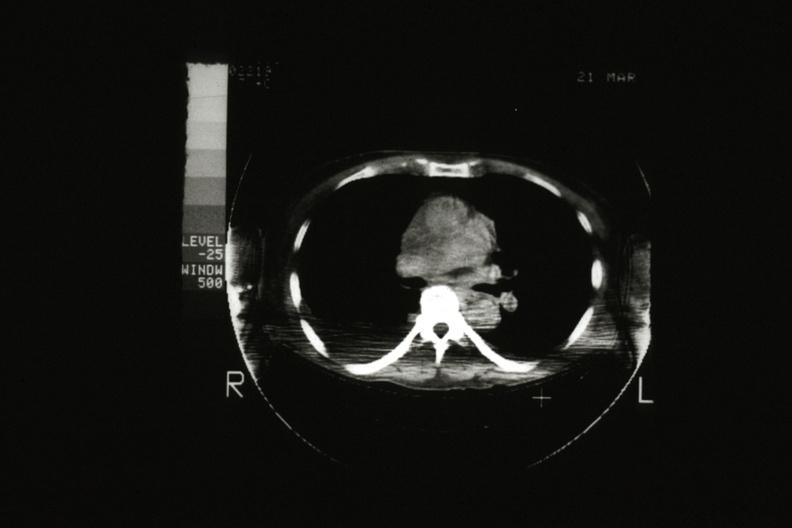what is present?
Answer the question using a single word or phrase. Thymus 